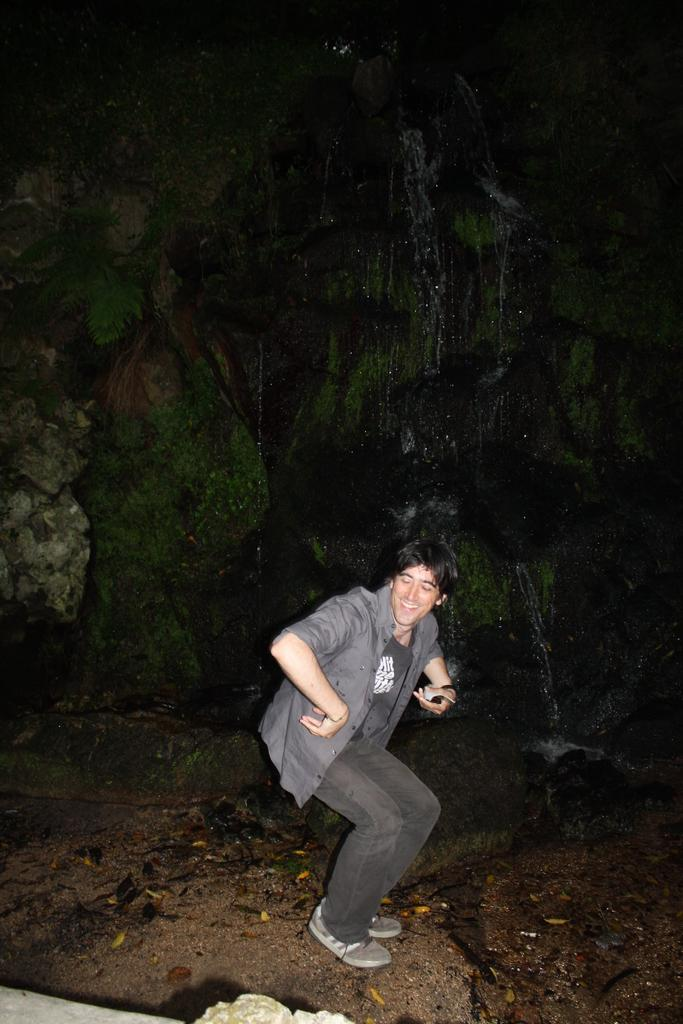What type of landscape feature is present in the image? There is a hill in the image. What natural element is also visible in the image? There is water in the image. Can you describe the person in the image? There is a man standing in the front of the image. What type of school can be seen in the background of the image? There is no school present in the image; it features a hill, water, and a man standing in the front. 